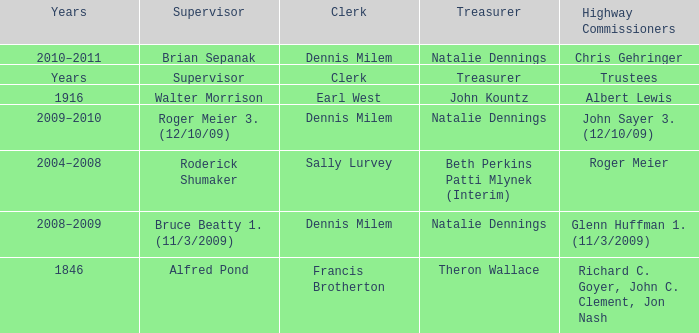When Treasurer was treasurer, who was the highway commissioner? Trustees. Give me the full table as a dictionary. {'header': ['Years', 'Supervisor', 'Clerk', 'Treasurer', 'Highway Commissioners'], 'rows': [['2010–2011', 'Brian Sepanak', 'Dennis Milem', 'Natalie Dennings', 'Chris Gehringer'], ['Years', 'Supervisor', 'Clerk', 'Treasurer', 'Trustees'], ['1916', 'Walter Morrison', 'Earl West', 'John Kountz', 'Albert Lewis'], ['2009–2010', 'Roger Meier 3. (12/10/09)', 'Dennis Milem', 'Natalie Dennings', 'John Sayer 3. (12/10/09)'], ['2004–2008', 'Roderick Shumaker', 'Sally Lurvey', 'Beth Perkins Patti Mlynek (Interim)', 'Roger Meier'], ['2008–2009', 'Bruce Beatty 1. (11/3/2009)', 'Dennis Milem', 'Natalie Dennings', 'Glenn Huffman 1. (11/3/2009)'], ['1846', 'Alfred Pond', 'Francis Brotherton', 'Theron Wallace', 'Richard C. Goyer, John C. Clement, Jon Nash']]} 